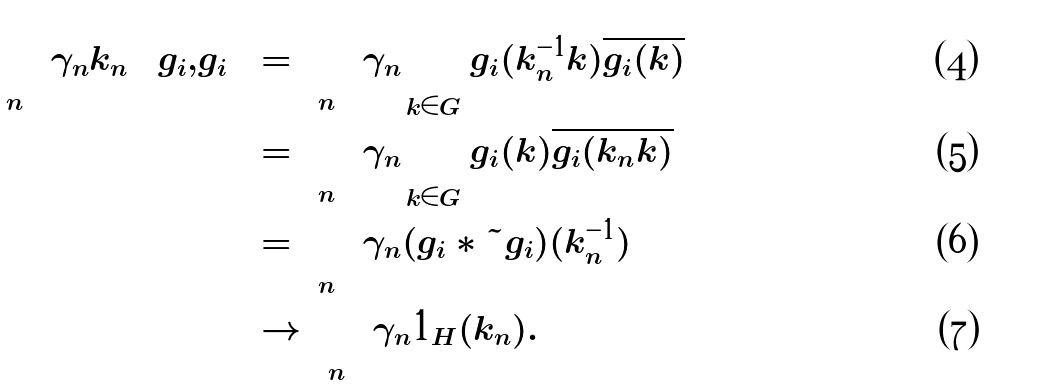Convert formula to latex. <formula><loc_0><loc_0><loc_500><loc_500>\left \langle \left ( \sum _ { n } \gamma _ { n } k _ { n } \right ) g _ { i } , g _ { i } \right \rangle & = \sum _ { n } \gamma _ { n } \sum _ { k \in G } g _ { i } ( k _ { n } ^ { - 1 } k ) \overline { g _ { i } ( k ) } \\ & = \sum _ { n } \gamma _ { n } \sum _ { k \in G } g _ { i } ( k ) \overline { g _ { i } ( k _ { n } k ) } \\ & = \sum _ { n } \gamma _ { n } ( g _ { i } * \tilde { g _ { i } } ) ( k _ { n } ^ { - 1 } ) \\ & \to \sum _ { n } \gamma _ { n } 1 _ { H } ( k _ { n } ) .</formula> 